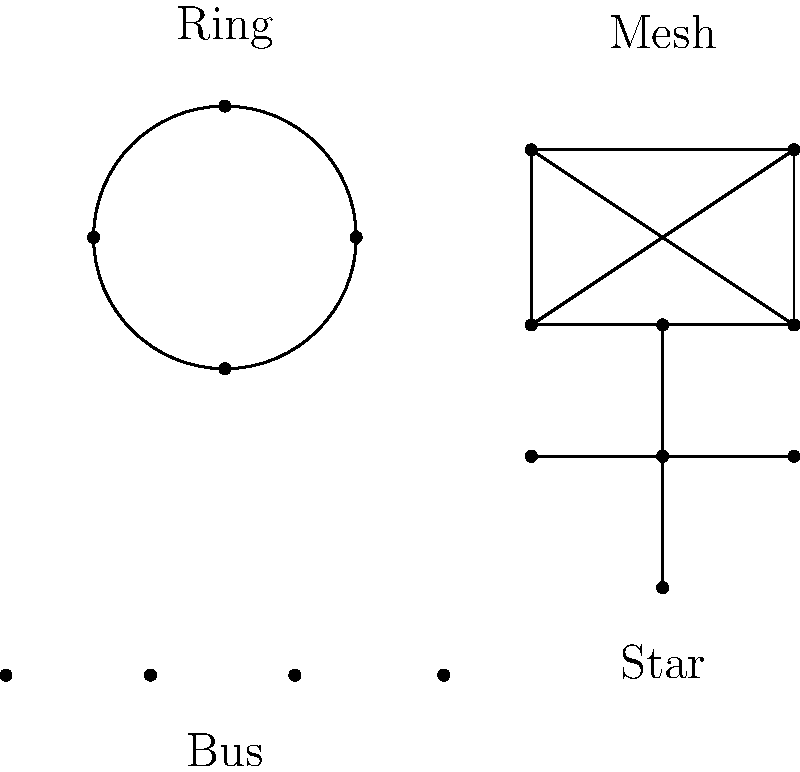As a C# programming instructor, you're explaining network topologies to your students. Which topology shown in the diagram would be most resilient to single-point failures and why? Let's analyze each topology in terms of resilience to single-point failures:

1. Bus Topology:
   - All devices share a single communication line.
   - If the main line fails, the entire network goes down.
   - Highly vulnerable to single-point failures.

2. Star Topology:
   - All devices connect to a central hub or switch.
   - If one device or its connection fails, others remain unaffected.
   - However, if the central hub fails, the entire network goes down.

3. Ring Topology:
   - Devices are connected in a circular manner.
   - A single failure can disrupt the entire network unless there's a redundant path.
   - Moderately vulnerable to single-point failures.

4. Mesh Topology:
   - Each device is connected to every other device.
   - If one connection fails, data can be routed through alternative paths.
   - Multiple connections provide redundancy and fault tolerance.
   - Most resilient to single-point failures among the given topologies.

The mesh topology is the most resilient because:
   a) It provides multiple paths for data transmission.
   b) Failure of a single node or connection doesn't isolate any other nodes.
   c) The network can continue to function even if multiple nodes or connections fail.

In C# terms, we could think of this as having multiple exception handling paths (try-catch blocks) rather than relying on a single point of failure.
Answer: Mesh topology 